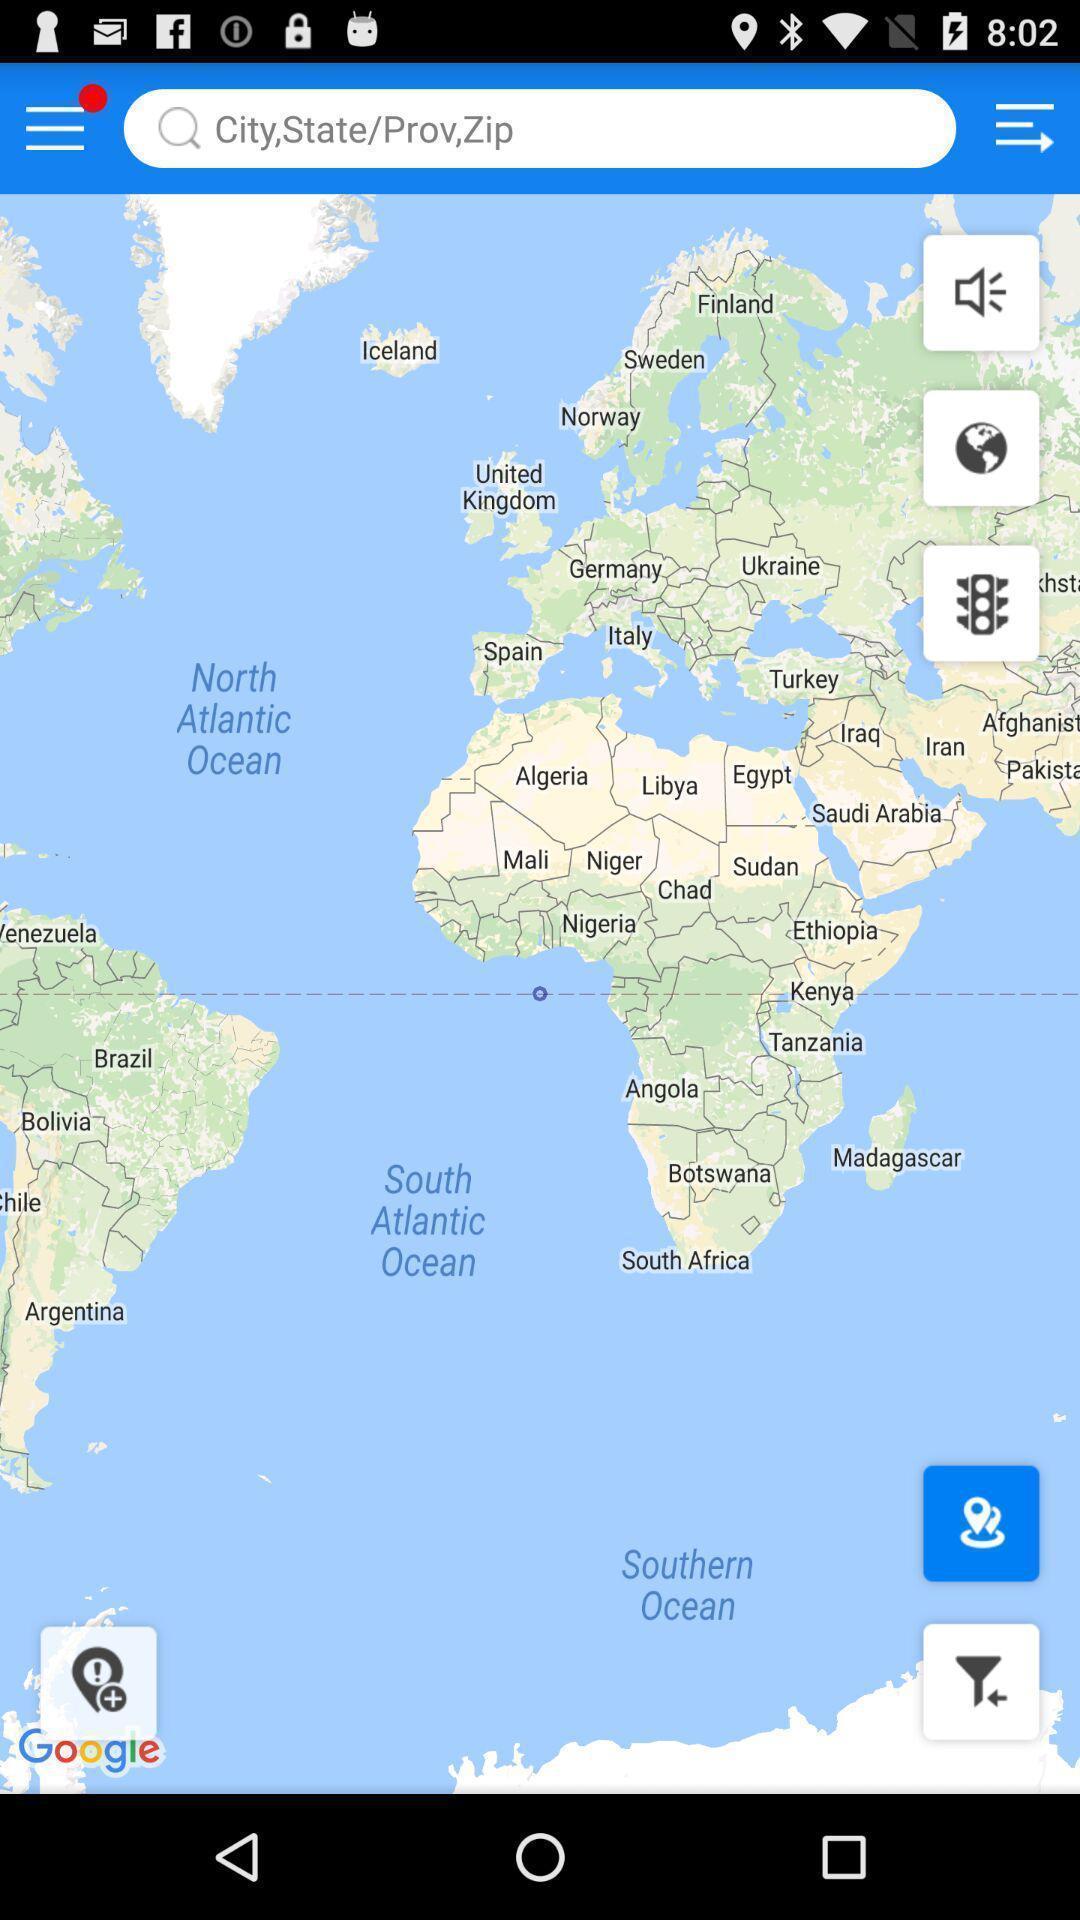Summarize the information in this screenshot. Screen showing the various countries in map. 